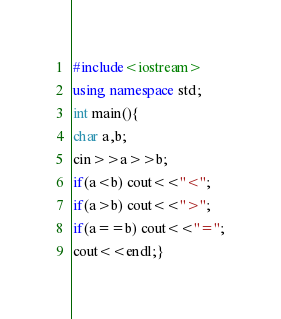Convert code to text. <code><loc_0><loc_0><loc_500><loc_500><_C++_>#include<iostream>
using namespace std;
int main(){
char a,b;
cin>>a>>b;
if(a<b) cout<<"<";
if(a>b) cout<<">";
if(a==b) cout<<"=";
cout<<endl;}</code> 